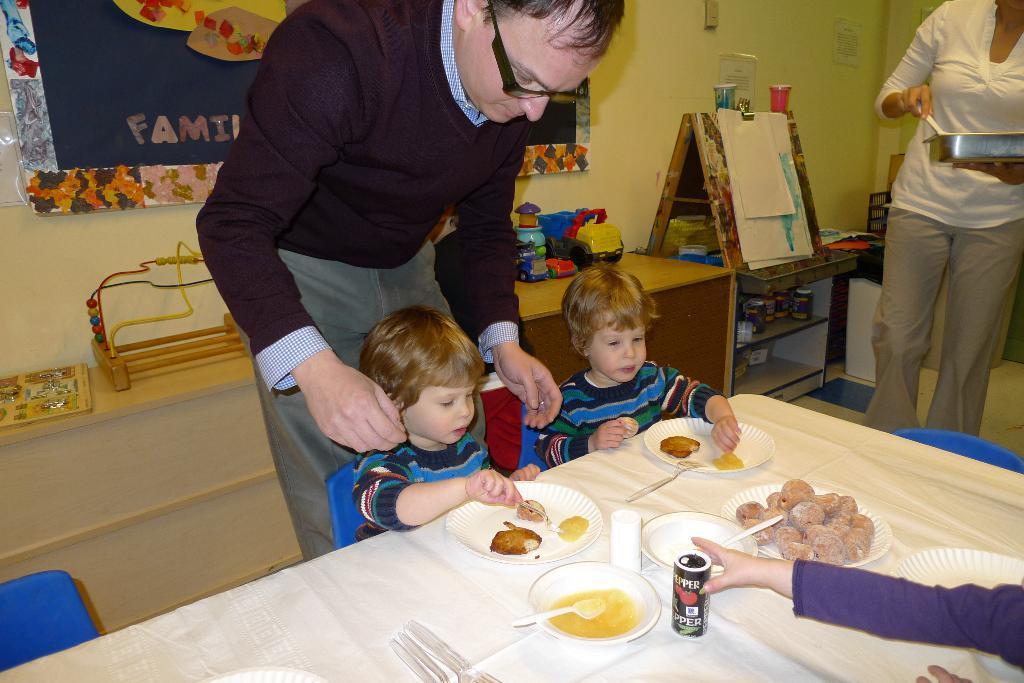How would you summarize this image in a sentence or two? In this picture I can see food items on the plates, there are spoons, forks, tin and a napkin on the table, there are chairs, there are two persons standing , a person holding a tray and an item, there are two kids sitting on the chairs, and in the background there is a board and papers attached to the wall, there are toys and some other objects on the cabinet. 